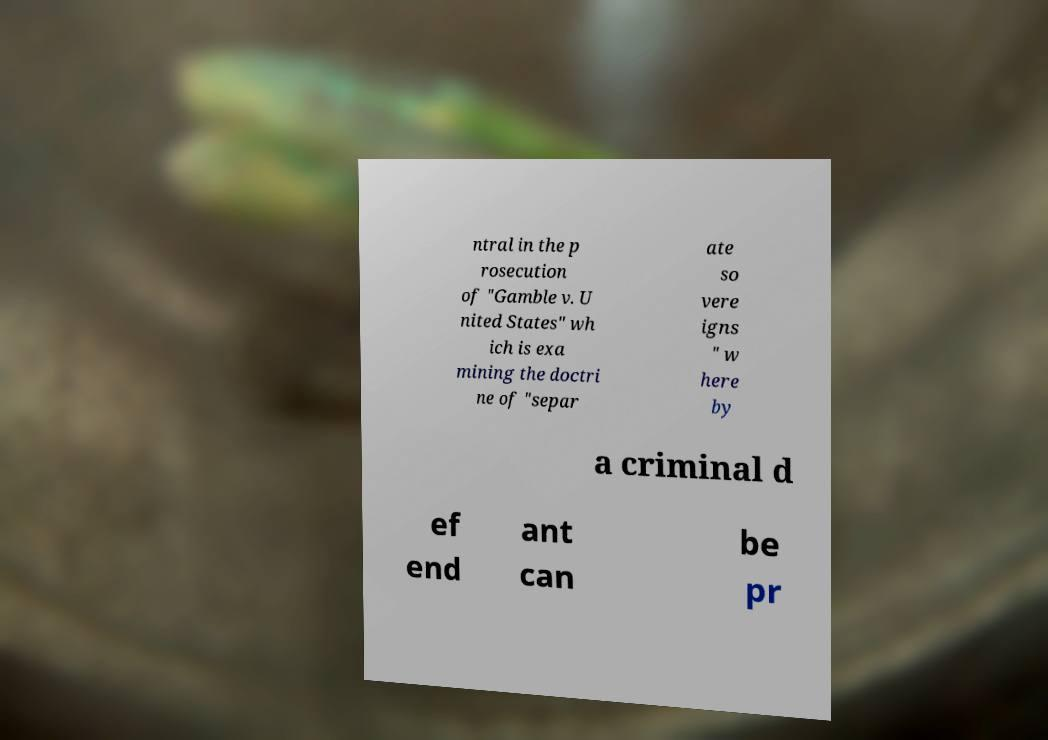Can you accurately transcribe the text from the provided image for me? ntral in the p rosecution of "Gamble v. U nited States" wh ich is exa mining the doctri ne of "separ ate so vere igns " w here by a criminal d ef end ant can be pr 